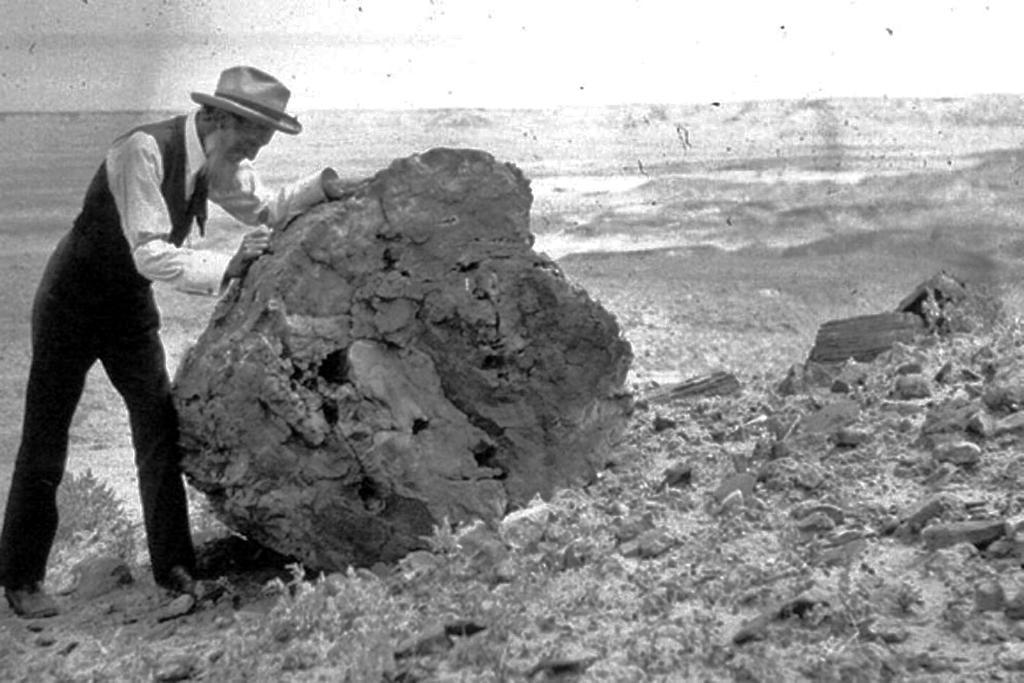What is the color scheme of the image? The image is black and white. Can you describe the person in the image? The person in the image is wearing a hat. What is the person doing in the image? The person is standing beside a rock and has their hands on the rock. What can be seen on the ground in the image? There are stones on the ground in the image. What type of grain is being discussed at the meeting in the image? There is no meeting or discussion of grain present in the image. What rule is being enforced by the person in the image? There is no indication of a rule or enforcement in the image. 